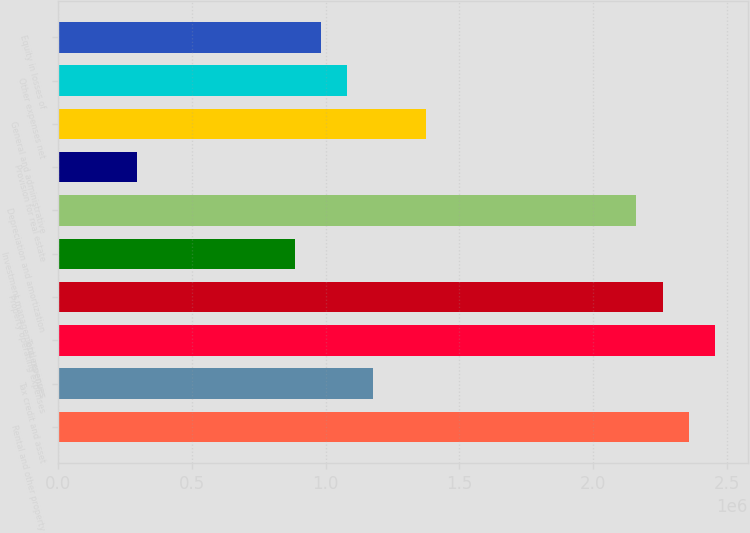<chart> <loc_0><loc_0><loc_500><loc_500><bar_chart><fcel>Rental and other property<fcel>Tax credit and asset<fcel>Total revenues<fcel>Property operating expenses<fcel>Investment management expenses<fcel>Depreciation and amortization<fcel>Provision for real estate<fcel>General and administrative<fcel>Other expenses net<fcel>Equity in losses of<nl><fcel>2.3566e+06<fcel>1.1783e+06<fcel>2.4548e+06<fcel>2.25841e+06<fcel>883727<fcel>2.16022e+06<fcel>294576<fcel>1.37469e+06<fcel>1.08011e+06<fcel>981919<nl></chart> 